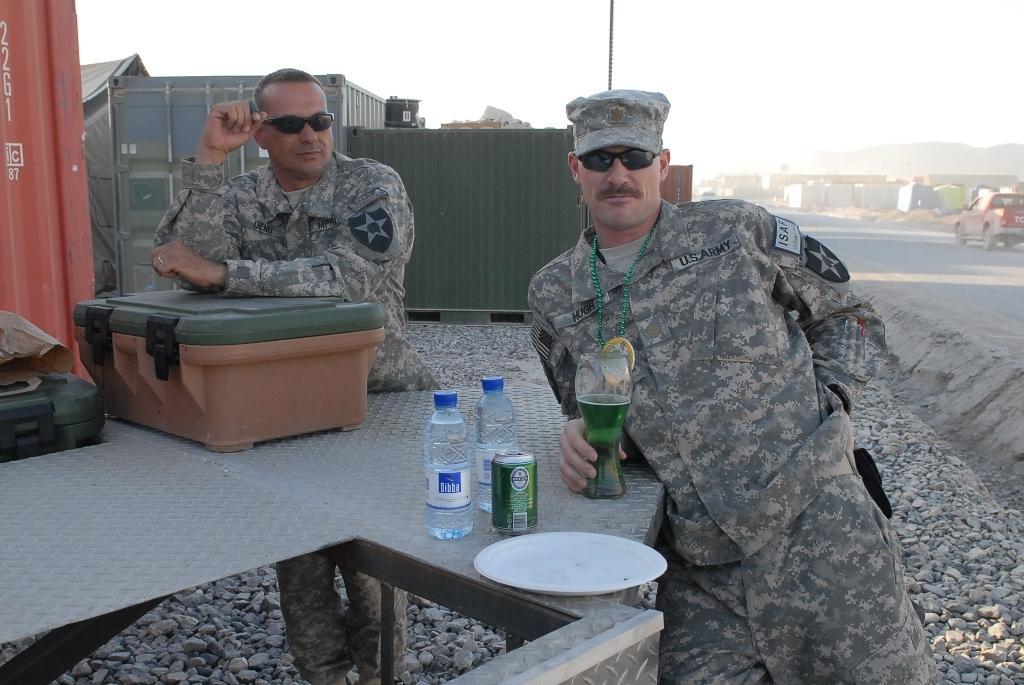Can you describe this image briefly? In this image we can see there are two persons standing near the table. There are bottles, plate, suitcase and glass. Right side, we can see the vehicle on the road. And there are containers, pole and sky. 